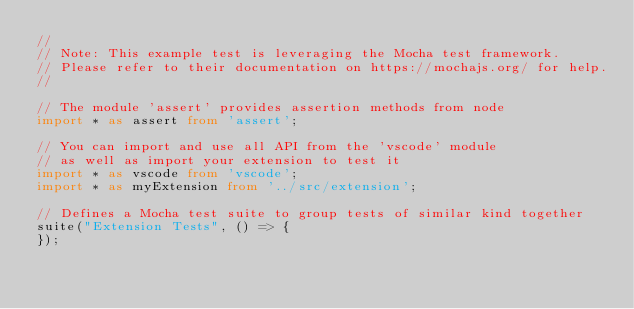<code> <loc_0><loc_0><loc_500><loc_500><_TypeScript_>// 
// Note: This example test is leveraging the Mocha test framework.
// Please refer to their documentation on https://mochajs.org/ for help.
//

// The module 'assert' provides assertion methods from node
import * as assert from 'assert';

// You can import and use all API from the 'vscode' module
// as well as import your extension to test it
import * as vscode from 'vscode';
import * as myExtension from '../src/extension';

// Defines a Mocha test suite to group tests of similar kind together
suite("Extension Tests", () => {
});</code> 